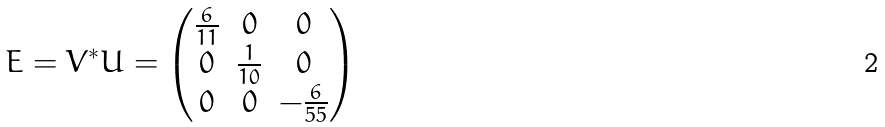<formula> <loc_0><loc_0><loc_500><loc_500>E = V ^ { * } U = \begin{pmatrix} \frac { 6 } { 1 1 } & 0 & 0 \\ 0 & \frac { 1 } { 1 0 } & 0 \\ 0 & 0 & - \frac { 6 } { 5 5 } \end{pmatrix}</formula> 